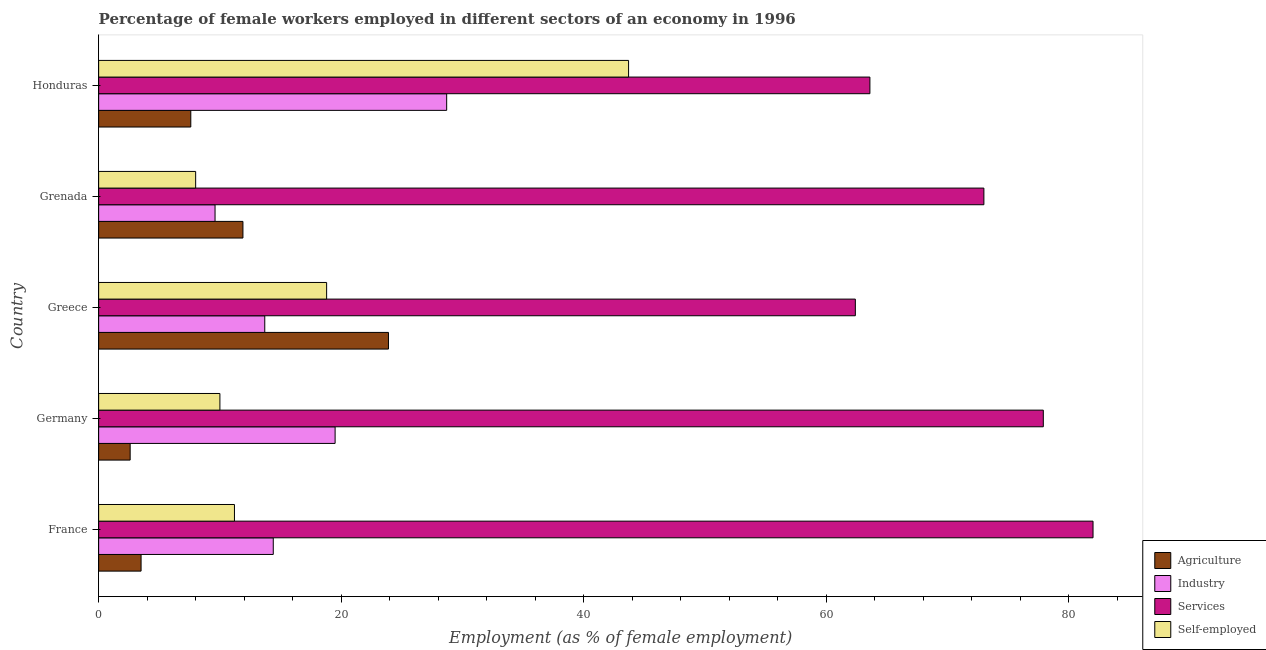How many different coloured bars are there?
Your answer should be compact. 4. How many bars are there on the 5th tick from the bottom?
Make the answer very short. 4. What is the percentage of self employed female workers in France?
Offer a very short reply. 11.2. Across all countries, what is the maximum percentage of female workers in services?
Your response must be concise. 82. Across all countries, what is the minimum percentage of female workers in agriculture?
Your answer should be very brief. 2.6. What is the total percentage of self employed female workers in the graph?
Offer a terse response. 91.7. What is the difference between the percentage of female workers in services in France and that in Greece?
Make the answer very short. 19.6. What is the difference between the percentage of female workers in industry in Greece and the percentage of self employed female workers in Germany?
Offer a terse response. 3.7. What is the average percentage of female workers in services per country?
Your response must be concise. 71.78. In how many countries, is the percentage of female workers in services greater than 76 %?
Offer a very short reply. 2. What is the ratio of the percentage of female workers in industry in Greece to that in Grenada?
Your answer should be compact. 1.43. What is the difference between the highest and the second highest percentage of female workers in services?
Offer a terse response. 4.1. What is the difference between the highest and the lowest percentage of self employed female workers?
Your answer should be compact. 35.7. Is it the case that in every country, the sum of the percentage of female workers in services and percentage of female workers in agriculture is greater than the sum of percentage of female workers in industry and percentage of self employed female workers?
Provide a succinct answer. Yes. What does the 4th bar from the top in Honduras represents?
Give a very brief answer. Agriculture. What does the 3rd bar from the bottom in Honduras represents?
Your answer should be very brief. Services. Is it the case that in every country, the sum of the percentage of female workers in agriculture and percentage of female workers in industry is greater than the percentage of female workers in services?
Ensure brevity in your answer.  No. How many bars are there?
Offer a terse response. 20. Are all the bars in the graph horizontal?
Ensure brevity in your answer.  Yes. What is the difference between two consecutive major ticks on the X-axis?
Give a very brief answer. 20. Does the graph contain grids?
Give a very brief answer. No. Where does the legend appear in the graph?
Keep it short and to the point. Bottom right. How many legend labels are there?
Ensure brevity in your answer.  4. What is the title of the graph?
Provide a short and direct response. Percentage of female workers employed in different sectors of an economy in 1996. Does "Insurance services" appear as one of the legend labels in the graph?
Provide a short and direct response. No. What is the label or title of the X-axis?
Provide a short and direct response. Employment (as % of female employment). What is the label or title of the Y-axis?
Keep it short and to the point. Country. What is the Employment (as % of female employment) in Agriculture in France?
Ensure brevity in your answer.  3.5. What is the Employment (as % of female employment) of Industry in France?
Provide a short and direct response. 14.4. What is the Employment (as % of female employment) in Self-employed in France?
Ensure brevity in your answer.  11.2. What is the Employment (as % of female employment) of Agriculture in Germany?
Make the answer very short. 2.6. What is the Employment (as % of female employment) of Industry in Germany?
Give a very brief answer. 19.5. What is the Employment (as % of female employment) in Services in Germany?
Ensure brevity in your answer.  77.9. What is the Employment (as % of female employment) in Agriculture in Greece?
Make the answer very short. 23.9. What is the Employment (as % of female employment) of Industry in Greece?
Ensure brevity in your answer.  13.7. What is the Employment (as % of female employment) in Services in Greece?
Provide a succinct answer. 62.4. What is the Employment (as % of female employment) in Self-employed in Greece?
Your response must be concise. 18.8. What is the Employment (as % of female employment) in Agriculture in Grenada?
Make the answer very short. 11.9. What is the Employment (as % of female employment) of Industry in Grenada?
Your response must be concise. 9.6. What is the Employment (as % of female employment) in Agriculture in Honduras?
Ensure brevity in your answer.  7.6. What is the Employment (as % of female employment) in Industry in Honduras?
Ensure brevity in your answer.  28.7. What is the Employment (as % of female employment) of Services in Honduras?
Your answer should be compact. 63.6. What is the Employment (as % of female employment) in Self-employed in Honduras?
Keep it short and to the point. 43.7. Across all countries, what is the maximum Employment (as % of female employment) of Agriculture?
Your response must be concise. 23.9. Across all countries, what is the maximum Employment (as % of female employment) of Industry?
Provide a short and direct response. 28.7. Across all countries, what is the maximum Employment (as % of female employment) in Services?
Make the answer very short. 82. Across all countries, what is the maximum Employment (as % of female employment) of Self-employed?
Offer a very short reply. 43.7. Across all countries, what is the minimum Employment (as % of female employment) of Agriculture?
Provide a short and direct response. 2.6. Across all countries, what is the minimum Employment (as % of female employment) in Industry?
Give a very brief answer. 9.6. Across all countries, what is the minimum Employment (as % of female employment) of Services?
Offer a terse response. 62.4. Across all countries, what is the minimum Employment (as % of female employment) in Self-employed?
Ensure brevity in your answer.  8. What is the total Employment (as % of female employment) in Agriculture in the graph?
Offer a terse response. 49.5. What is the total Employment (as % of female employment) of Industry in the graph?
Give a very brief answer. 85.9. What is the total Employment (as % of female employment) in Services in the graph?
Provide a succinct answer. 358.9. What is the total Employment (as % of female employment) of Self-employed in the graph?
Provide a short and direct response. 91.7. What is the difference between the Employment (as % of female employment) in Agriculture in France and that in Greece?
Keep it short and to the point. -20.4. What is the difference between the Employment (as % of female employment) of Services in France and that in Greece?
Give a very brief answer. 19.6. What is the difference between the Employment (as % of female employment) of Agriculture in France and that in Grenada?
Make the answer very short. -8.4. What is the difference between the Employment (as % of female employment) in Agriculture in France and that in Honduras?
Your response must be concise. -4.1. What is the difference between the Employment (as % of female employment) in Industry in France and that in Honduras?
Your answer should be very brief. -14.3. What is the difference between the Employment (as % of female employment) of Services in France and that in Honduras?
Ensure brevity in your answer.  18.4. What is the difference between the Employment (as % of female employment) in Self-employed in France and that in Honduras?
Give a very brief answer. -32.5. What is the difference between the Employment (as % of female employment) in Agriculture in Germany and that in Greece?
Your response must be concise. -21.3. What is the difference between the Employment (as % of female employment) in Self-employed in Germany and that in Greece?
Provide a succinct answer. -8.8. What is the difference between the Employment (as % of female employment) of Agriculture in Germany and that in Grenada?
Provide a succinct answer. -9.3. What is the difference between the Employment (as % of female employment) of Industry in Germany and that in Grenada?
Offer a very short reply. 9.9. What is the difference between the Employment (as % of female employment) of Services in Germany and that in Grenada?
Your answer should be compact. 4.9. What is the difference between the Employment (as % of female employment) in Agriculture in Germany and that in Honduras?
Make the answer very short. -5. What is the difference between the Employment (as % of female employment) in Industry in Germany and that in Honduras?
Your response must be concise. -9.2. What is the difference between the Employment (as % of female employment) of Services in Germany and that in Honduras?
Keep it short and to the point. 14.3. What is the difference between the Employment (as % of female employment) in Self-employed in Germany and that in Honduras?
Offer a very short reply. -33.7. What is the difference between the Employment (as % of female employment) of Industry in Greece and that in Grenada?
Ensure brevity in your answer.  4.1. What is the difference between the Employment (as % of female employment) in Services in Greece and that in Grenada?
Your answer should be very brief. -10.6. What is the difference between the Employment (as % of female employment) in Industry in Greece and that in Honduras?
Give a very brief answer. -15. What is the difference between the Employment (as % of female employment) of Services in Greece and that in Honduras?
Your answer should be very brief. -1.2. What is the difference between the Employment (as % of female employment) of Self-employed in Greece and that in Honduras?
Offer a terse response. -24.9. What is the difference between the Employment (as % of female employment) of Industry in Grenada and that in Honduras?
Ensure brevity in your answer.  -19.1. What is the difference between the Employment (as % of female employment) of Services in Grenada and that in Honduras?
Your answer should be very brief. 9.4. What is the difference between the Employment (as % of female employment) in Self-employed in Grenada and that in Honduras?
Make the answer very short. -35.7. What is the difference between the Employment (as % of female employment) in Agriculture in France and the Employment (as % of female employment) in Industry in Germany?
Your answer should be very brief. -16. What is the difference between the Employment (as % of female employment) of Agriculture in France and the Employment (as % of female employment) of Services in Germany?
Give a very brief answer. -74.4. What is the difference between the Employment (as % of female employment) in Agriculture in France and the Employment (as % of female employment) in Self-employed in Germany?
Offer a very short reply. -6.5. What is the difference between the Employment (as % of female employment) in Industry in France and the Employment (as % of female employment) in Services in Germany?
Give a very brief answer. -63.5. What is the difference between the Employment (as % of female employment) of Services in France and the Employment (as % of female employment) of Self-employed in Germany?
Your answer should be very brief. 72. What is the difference between the Employment (as % of female employment) in Agriculture in France and the Employment (as % of female employment) in Industry in Greece?
Offer a terse response. -10.2. What is the difference between the Employment (as % of female employment) in Agriculture in France and the Employment (as % of female employment) in Services in Greece?
Your response must be concise. -58.9. What is the difference between the Employment (as % of female employment) of Agriculture in France and the Employment (as % of female employment) of Self-employed in Greece?
Provide a short and direct response. -15.3. What is the difference between the Employment (as % of female employment) of Industry in France and the Employment (as % of female employment) of Services in Greece?
Offer a very short reply. -48. What is the difference between the Employment (as % of female employment) in Services in France and the Employment (as % of female employment) in Self-employed in Greece?
Offer a very short reply. 63.2. What is the difference between the Employment (as % of female employment) in Agriculture in France and the Employment (as % of female employment) in Services in Grenada?
Your answer should be very brief. -69.5. What is the difference between the Employment (as % of female employment) of Agriculture in France and the Employment (as % of female employment) of Self-employed in Grenada?
Offer a terse response. -4.5. What is the difference between the Employment (as % of female employment) of Industry in France and the Employment (as % of female employment) of Services in Grenada?
Keep it short and to the point. -58.6. What is the difference between the Employment (as % of female employment) of Industry in France and the Employment (as % of female employment) of Self-employed in Grenada?
Make the answer very short. 6.4. What is the difference between the Employment (as % of female employment) in Services in France and the Employment (as % of female employment) in Self-employed in Grenada?
Your answer should be very brief. 74. What is the difference between the Employment (as % of female employment) of Agriculture in France and the Employment (as % of female employment) of Industry in Honduras?
Make the answer very short. -25.2. What is the difference between the Employment (as % of female employment) of Agriculture in France and the Employment (as % of female employment) of Services in Honduras?
Offer a terse response. -60.1. What is the difference between the Employment (as % of female employment) in Agriculture in France and the Employment (as % of female employment) in Self-employed in Honduras?
Make the answer very short. -40.2. What is the difference between the Employment (as % of female employment) in Industry in France and the Employment (as % of female employment) in Services in Honduras?
Your answer should be very brief. -49.2. What is the difference between the Employment (as % of female employment) of Industry in France and the Employment (as % of female employment) of Self-employed in Honduras?
Make the answer very short. -29.3. What is the difference between the Employment (as % of female employment) in Services in France and the Employment (as % of female employment) in Self-employed in Honduras?
Keep it short and to the point. 38.3. What is the difference between the Employment (as % of female employment) in Agriculture in Germany and the Employment (as % of female employment) in Services in Greece?
Your answer should be compact. -59.8. What is the difference between the Employment (as % of female employment) of Agriculture in Germany and the Employment (as % of female employment) of Self-employed in Greece?
Provide a short and direct response. -16.2. What is the difference between the Employment (as % of female employment) in Industry in Germany and the Employment (as % of female employment) in Services in Greece?
Offer a terse response. -42.9. What is the difference between the Employment (as % of female employment) of Industry in Germany and the Employment (as % of female employment) of Self-employed in Greece?
Keep it short and to the point. 0.7. What is the difference between the Employment (as % of female employment) in Services in Germany and the Employment (as % of female employment) in Self-employed in Greece?
Make the answer very short. 59.1. What is the difference between the Employment (as % of female employment) of Agriculture in Germany and the Employment (as % of female employment) of Services in Grenada?
Your answer should be very brief. -70.4. What is the difference between the Employment (as % of female employment) of Agriculture in Germany and the Employment (as % of female employment) of Self-employed in Grenada?
Keep it short and to the point. -5.4. What is the difference between the Employment (as % of female employment) in Industry in Germany and the Employment (as % of female employment) in Services in Grenada?
Your answer should be compact. -53.5. What is the difference between the Employment (as % of female employment) in Industry in Germany and the Employment (as % of female employment) in Self-employed in Grenada?
Your answer should be very brief. 11.5. What is the difference between the Employment (as % of female employment) in Services in Germany and the Employment (as % of female employment) in Self-employed in Grenada?
Your answer should be very brief. 69.9. What is the difference between the Employment (as % of female employment) in Agriculture in Germany and the Employment (as % of female employment) in Industry in Honduras?
Offer a very short reply. -26.1. What is the difference between the Employment (as % of female employment) in Agriculture in Germany and the Employment (as % of female employment) in Services in Honduras?
Ensure brevity in your answer.  -61. What is the difference between the Employment (as % of female employment) in Agriculture in Germany and the Employment (as % of female employment) in Self-employed in Honduras?
Keep it short and to the point. -41.1. What is the difference between the Employment (as % of female employment) in Industry in Germany and the Employment (as % of female employment) in Services in Honduras?
Provide a short and direct response. -44.1. What is the difference between the Employment (as % of female employment) in Industry in Germany and the Employment (as % of female employment) in Self-employed in Honduras?
Your answer should be very brief. -24.2. What is the difference between the Employment (as % of female employment) in Services in Germany and the Employment (as % of female employment) in Self-employed in Honduras?
Provide a succinct answer. 34.2. What is the difference between the Employment (as % of female employment) in Agriculture in Greece and the Employment (as % of female employment) in Services in Grenada?
Provide a succinct answer. -49.1. What is the difference between the Employment (as % of female employment) of Industry in Greece and the Employment (as % of female employment) of Services in Grenada?
Offer a terse response. -59.3. What is the difference between the Employment (as % of female employment) in Services in Greece and the Employment (as % of female employment) in Self-employed in Grenada?
Your response must be concise. 54.4. What is the difference between the Employment (as % of female employment) of Agriculture in Greece and the Employment (as % of female employment) of Services in Honduras?
Offer a terse response. -39.7. What is the difference between the Employment (as % of female employment) of Agriculture in Greece and the Employment (as % of female employment) of Self-employed in Honduras?
Provide a short and direct response. -19.8. What is the difference between the Employment (as % of female employment) of Industry in Greece and the Employment (as % of female employment) of Services in Honduras?
Provide a short and direct response. -49.9. What is the difference between the Employment (as % of female employment) in Services in Greece and the Employment (as % of female employment) in Self-employed in Honduras?
Your answer should be very brief. 18.7. What is the difference between the Employment (as % of female employment) of Agriculture in Grenada and the Employment (as % of female employment) of Industry in Honduras?
Offer a very short reply. -16.8. What is the difference between the Employment (as % of female employment) in Agriculture in Grenada and the Employment (as % of female employment) in Services in Honduras?
Make the answer very short. -51.7. What is the difference between the Employment (as % of female employment) in Agriculture in Grenada and the Employment (as % of female employment) in Self-employed in Honduras?
Ensure brevity in your answer.  -31.8. What is the difference between the Employment (as % of female employment) in Industry in Grenada and the Employment (as % of female employment) in Services in Honduras?
Your answer should be compact. -54. What is the difference between the Employment (as % of female employment) of Industry in Grenada and the Employment (as % of female employment) of Self-employed in Honduras?
Provide a short and direct response. -34.1. What is the difference between the Employment (as % of female employment) of Services in Grenada and the Employment (as % of female employment) of Self-employed in Honduras?
Make the answer very short. 29.3. What is the average Employment (as % of female employment) of Agriculture per country?
Provide a succinct answer. 9.9. What is the average Employment (as % of female employment) of Industry per country?
Provide a succinct answer. 17.18. What is the average Employment (as % of female employment) in Services per country?
Ensure brevity in your answer.  71.78. What is the average Employment (as % of female employment) of Self-employed per country?
Ensure brevity in your answer.  18.34. What is the difference between the Employment (as % of female employment) of Agriculture and Employment (as % of female employment) of Services in France?
Your answer should be very brief. -78.5. What is the difference between the Employment (as % of female employment) of Agriculture and Employment (as % of female employment) of Self-employed in France?
Ensure brevity in your answer.  -7.7. What is the difference between the Employment (as % of female employment) of Industry and Employment (as % of female employment) of Services in France?
Your answer should be compact. -67.6. What is the difference between the Employment (as % of female employment) of Services and Employment (as % of female employment) of Self-employed in France?
Offer a very short reply. 70.8. What is the difference between the Employment (as % of female employment) of Agriculture and Employment (as % of female employment) of Industry in Germany?
Offer a very short reply. -16.9. What is the difference between the Employment (as % of female employment) of Agriculture and Employment (as % of female employment) of Services in Germany?
Offer a terse response. -75.3. What is the difference between the Employment (as % of female employment) of Agriculture and Employment (as % of female employment) of Self-employed in Germany?
Ensure brevity in your answer.  -7.4. What is the difference between the Employment (as % of female employment) of Industry and Employment (as % of female employment) of Services in Germany?
Ensure brevity in your answer.  -58.4. What is the difference between the Employment (as % of female employment) in Industry and Employment (as % of female employment) in Self-employed in Germany?
Offer a terse response. 9.5. What is the difference between the Employment (as % of female employment) of Services and Employment (as % of female employment) of Self-employed in Germany?
Your answer should be very brief. 67.9. What is the difference between the Employment (as % of female employment) in Agriculture and Employment (as % of female employment) in Services in Greece?
Offer a very short reply. -38.5. What is the difference between the Employment (as % of female employment) of Agriculture and Employment (as % of female employment) of Self-employed in Greece?
Provide a short and direct response. 5.1. What is the difference between the Employment (as % of female employment) in Industry and Employment (as % of female employment) in Services in Greece?
Make the answer very short. -48.7. What is the difference between the Employment (as % of female employment) of Services and Employment (as % of female employment) of Self-employed in Greece?
Offer a terse response. 43.6. What is the difference between the Employment (as % of female employment) of Agriculture and Employment (as % of female employment) of Services in Grenada?
Your answer should be compact. -61.1. What is the difference between the Employment (as % of female employment) of Agriculture and Employment (as % of female employment) of Self-employed in Grenada?
Your answer should be compact. 3.9. What is the difference between the Employment (as % of female employment) of Industry and Employment (as % of female employment) of Services in Grenada?
Ensure brevity in your answer.  -63.4. What is the difference between the Employment (as % of female employment) in Agriculture and Employment (as % of female employment) in Industry in Honduras?
Offer a terse response. -21.1. What is the difference between the Employment (as % of female employment) of Agriculture and Employment (as % of female employment) of Services in Honduras?
Provide a short and direct response. -56. What is the difference between the Employment (as % of female employment) in Agriculture and Employment (as % of female employment) in Self-employed in Honduras?
Give a very brief answer. -36.1. What is the difference between the Employment (as % of female employment) in Industry and Employment (as % of female employment) in Services in Honduras?
Your response must be concise. -34.9. What is the difference between the Employment (as % of female employment) in Services and Employment (as % of female employment) in Self-employed in Honduras?
Ensure brevity in your answer.  19.9. What is the ratio of the Employment (as % of female employment) of Agriculture in France to that in Germany?
Provide a short and direct response. 1.35. What is the ratio of the Employment (as % of female employment) in Industry in France to that in Germany?
Keep it short and to the point. 0.74. What is the ratio of the Employment (as % of female employment) of Services in France to that in Germany?
Your response must be concise. 1.05. What is the ratio of the Employment (as % of female employment) in Self-employed in France to that in Germany?
Offer a terse response. 1.12. What is the ratio of the Employment (as % of female employment) in Agriculture in France to that in Greece?
Your answer should be very brief. 0.15. What is the ratio of the Employment (as % of female employment) in Industry in France to that in Greece?
Ensure brevity in your answer.  1.05. What is the ratio of the Employment (as % of female employment) of Services in France to that in Greece?
Give a very brief answer. 1.31. What is the ratio of the Employment (as % of female employment) of Self-employed in France to that in Greece?
Offer a terse response. 0.6. What is the ratio of the Employment (as % of female employment) in Agriculture in France to that in Grenada?
Your response must be concise. 0.29. What is the ratio of the Employment (as % of female employment) in Services in France to that in Grenada?
Your response must be concise. 1.12. What is the ratio of the Employment (as % of female employment) in Self-employed in France to that in Grenada?
Your answer should be compact. 1.4. What is the ratio of the Employment (as % of female employment) in Agriculture in France to that in Honduras?
Make the answer very short. 0.46. What is the ratio of the Employment (as % of female employment) in Industry in France to that in Honduras?
Provide a short and direct response. 0.5. What is the ratio of the Employment (as % of female employment) in Services in France to that in Honduras?
Keep it short and to the point. 1.29. What is the ratio of the Employment (as % of female employment) of Self-employed in France to that in Honduras?
Your answer should be very brief. 0.26. What is the ratio of the Employment (as % of female employment) of Agriculture in Germany to that in Greece?
Provide a short and direct response. 0.11. What is the ratio of the Employment (as % of female employment) of Industry in Germany to that in Greece?
Give a very brief answer. 1.42. What is the ratio of the Employment (as % of female employment) in Services in Germany to that in Greece?
Your answer should be very brief. 1.25. What is the ratio of the Employment (as % of female employment) of Self-employed in Germany to that in Greece?
Offer a very short reply. 0.53. What is the ratio of the Employment (as % of female employment) of Agriculture in Germany to that in Grenada?
Your answer should be very brief. 0.22. What is the ratio of the Employment (as % of female employment) of Industry in Germany to that in Grenada?
Your answer should be very brief. 2.03. What is the ratio of the Employment (as % of female employment) in Services in Germany to that in Grenada?
Your answer should be very brief. 1.07. What is the ratio of the Employment (as % of female employment) of Agriculture in Germany to that in Honduras?
Provide a succinct answer. 0.34. What is the ratio of the Employment (as % of female employment) of Industry in Germany to that in Honduras?
Provide a succinct answer. 0.68. What is the ratio of the Employment (as % of female employment) in Services in Germany to that in Honduras?
Your answer should be compact. 1.22. What is the ratio of the Employment (as % of female employment) in Self-employed in Germany to that in Honduras?
Your response must be concise. 0.23. What is the ratio of the Employment (as % of female employment) in Agriculture in Greece to that in Grenada?
Offer a very short reply. 2.01. What is the ratio of the Employment (as % of female employment) in Industry in Greece to that in Grenada?
Give a very brief answer. 1.43. What is the ratio of the Employment (as % of female employment) of Services in Greece to that in Grenada?
Your response must be concise. 0.85. What is the ratio of the Employment (as % of female employment) in Self-employed in Greece to that in Grenada?
Make the answer very short. 2.35. What is the ratio of the Employment (as % of female employment) of Agriculture in Greece to that in Honduras?
Provide a succinct answer. 3.14. What is the ratio of the Employment (as % of female employment) in Industry in Greece to that in Honduras?
Give a very brief answer. 0.48. What is the ratio of the Employment (as % of female employment) of Services in Greece to that in Honduras?
Your response must be concise. 0.98. What is the ratio of the Employment (as % of female employment) in Self-employed in Greece to that in Honduras?
Ensure brevity in your answer.  0.43. What is the ratio of the Employment (as % of female employment) of Agriculture in Grenada to that in Honduras?
Provide a short and direct response. 1.57. What is the ratio of the Employment (as % of female employment) in Industry in Grenada to that in Honduras?
Your answer should be very brief. 0.33. What is the ratio of the Employment (as % of female employment) of Services in Grenada to that in Honduras?
Your answer should be compact. 1.15. What is the ratio of the Employment (as % of female employment) of Self-employed in Grenada to that in Honduras?
Ensure brevity in your answer.  0.18. What is the difference between the highest and the second highest Employment (as % of female employment) in Agriculture?
Your response must be concise. 12. What is the difference between the highest and the second highest Employment (as % of female employment) in Industry?
Your answer should be compact. 9.2. What is the difference between the highest and the second highest Employment (as % of female employment) of Services?
Your answer should be compact. 4.1. What is the difference between the highest and the second highest Employment (as % of female employment) in Self-employed?
Offer a very short reply. 24.9. What is the difference between the highest and the lowest Employment (as % of female employment) of Agriculture?
Provide a succinct answer. 21.3. What is the difference between the highest and the lowest Employment (as % of female employment) of Services?
Make the answer very short. 19.6. What is the difference between the highest and the lowest Employment (as % of female employment) of Self-employed?
Your response must be concise. 35.7. 